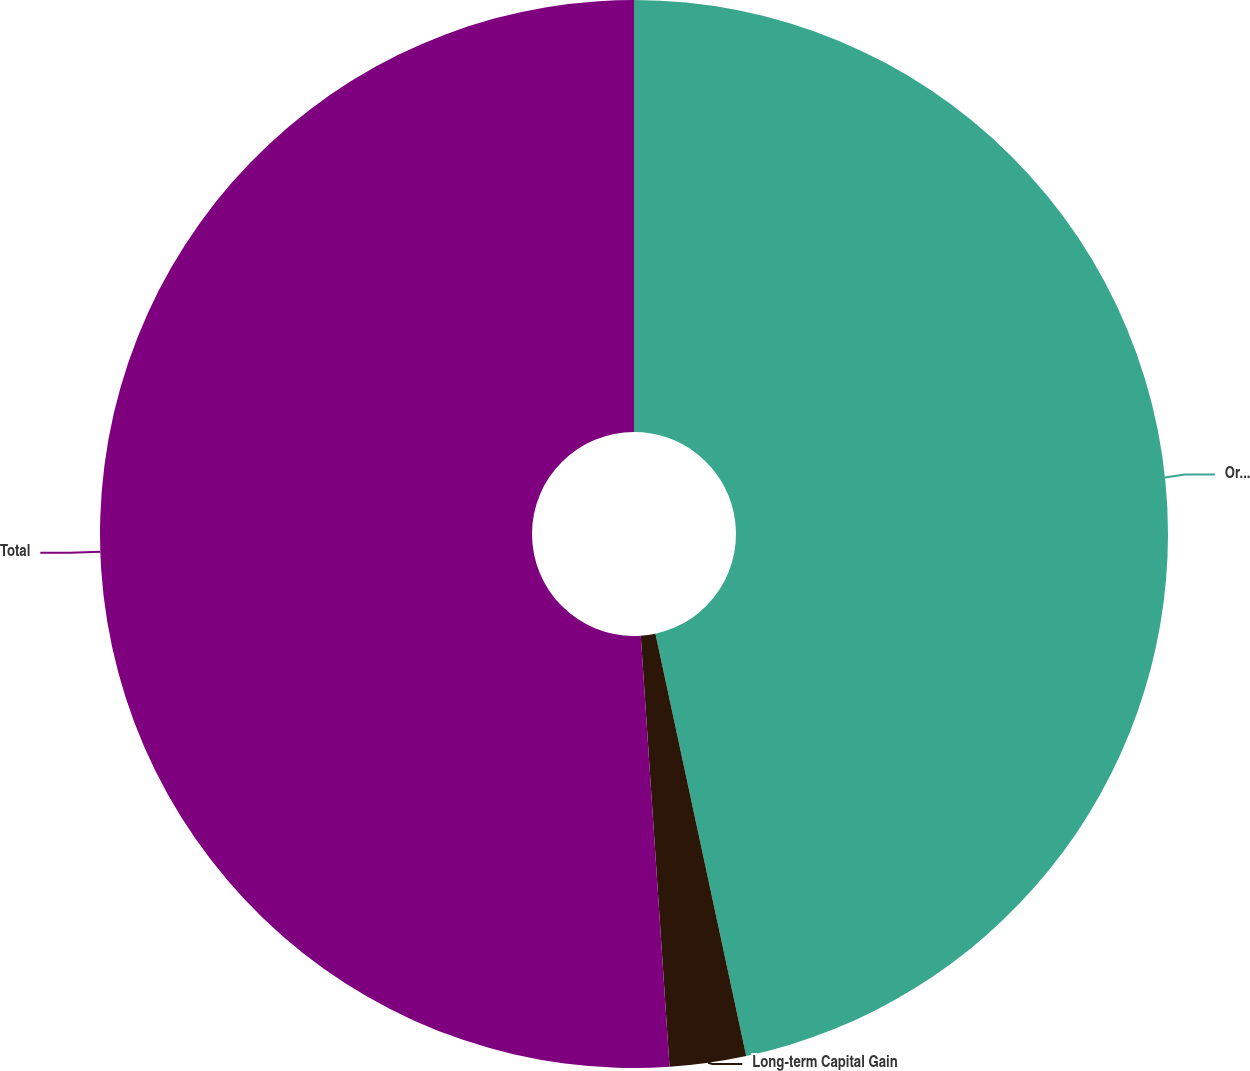Convert chart to OTSL. <chart><loc_0><loc_0><loc_500><loc_500><pie_chart><fcel>Ordinary Income<fcel>Long-term Capital Gain<fcel>Total<nl><fcel>46.63%<fcel>2.31%<fcel>51.06%<nl></chart> 